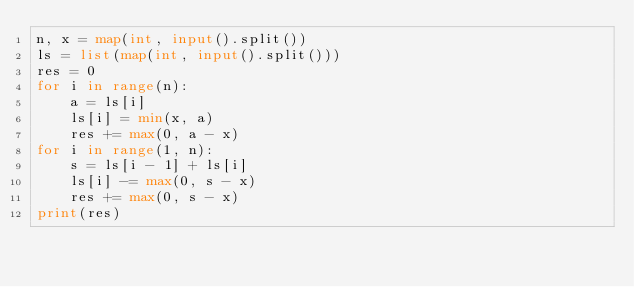<code> <loc_0><loc_0><loc_500><loc_500><_Python_>n, x = map(int, input().split())
ls = list(map(int, input().split()))
res = 0
for i in range(n):
    a = ls[i]
    ls[i] = min(x, a)
    res += max(0, a - x)
for i in range(1, n):
    s = ls[i - 1] + ls[i]
    ls[i] -= max(0, s - x)
    res += max(0, s - x)
print(res)</code> 